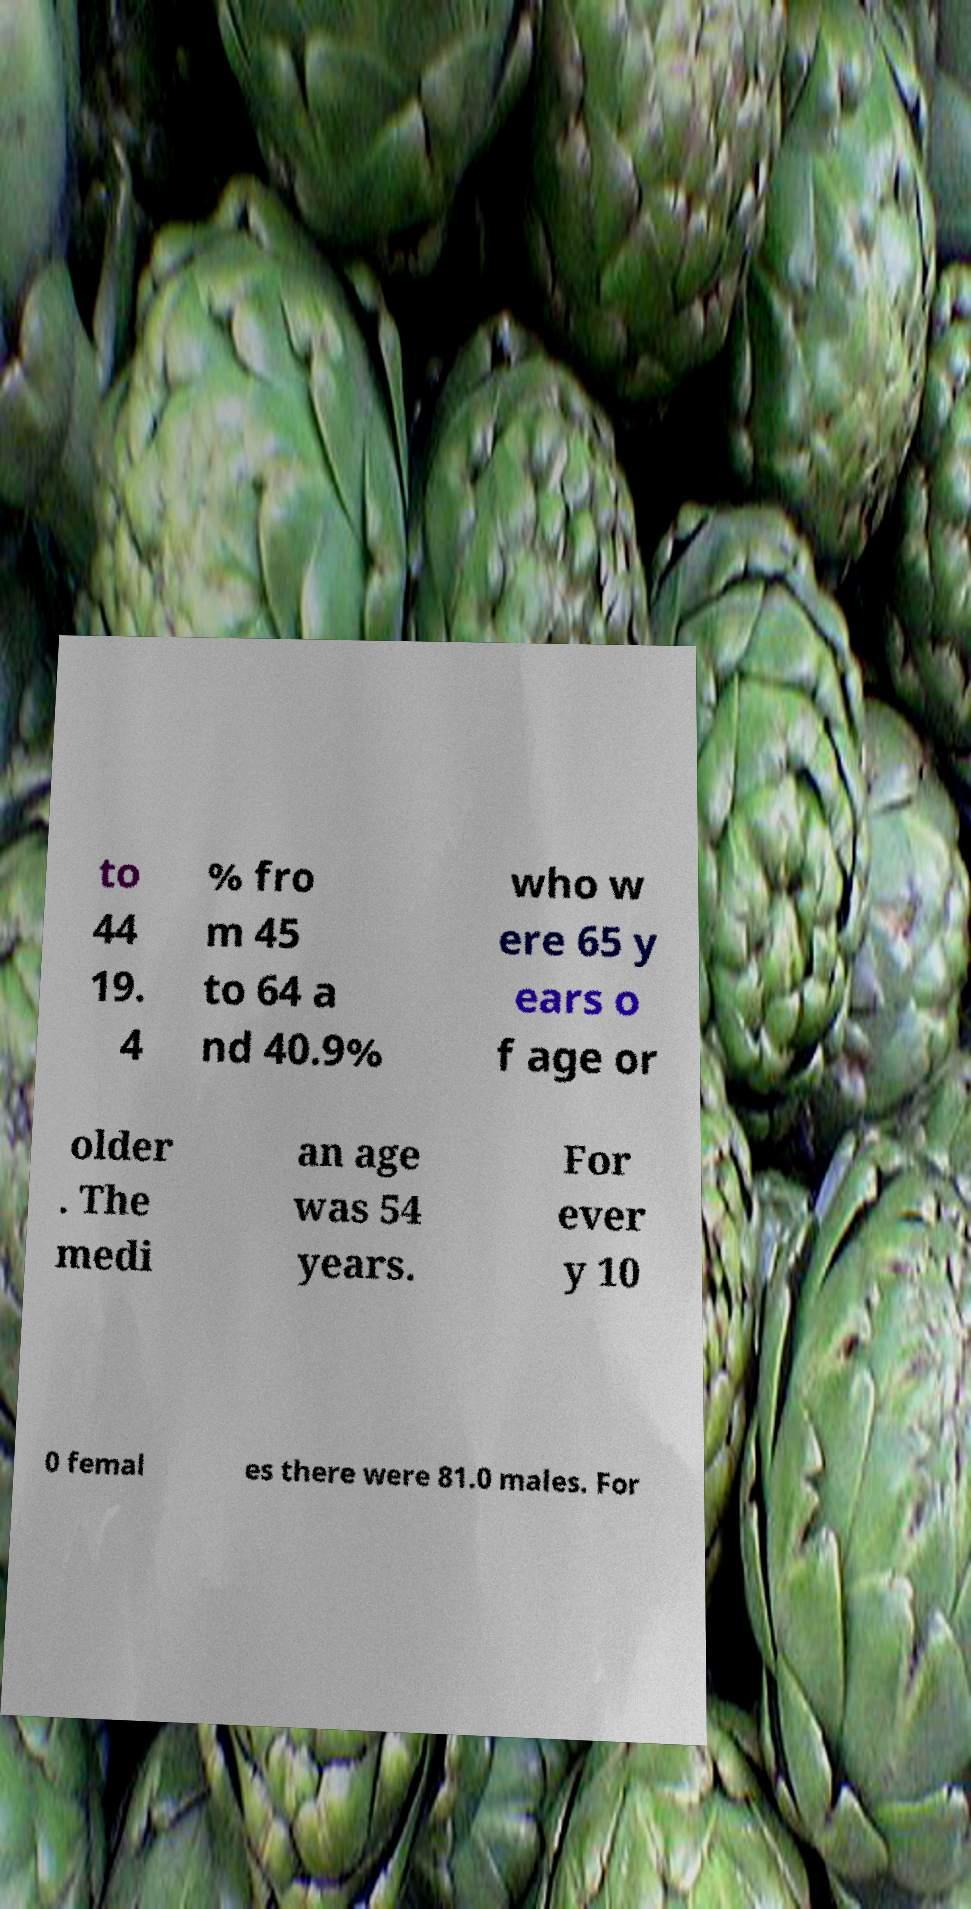For documentation purposes, I need the text within this image transcribed. Could you provide that? to 44 19. 4 % fro m 45 to 64 a nd 40.9% who w ere 65 y ears o f age or older . The medi an age was 54 years. For ever y 10 0 femal es there were 81.0 males. For 